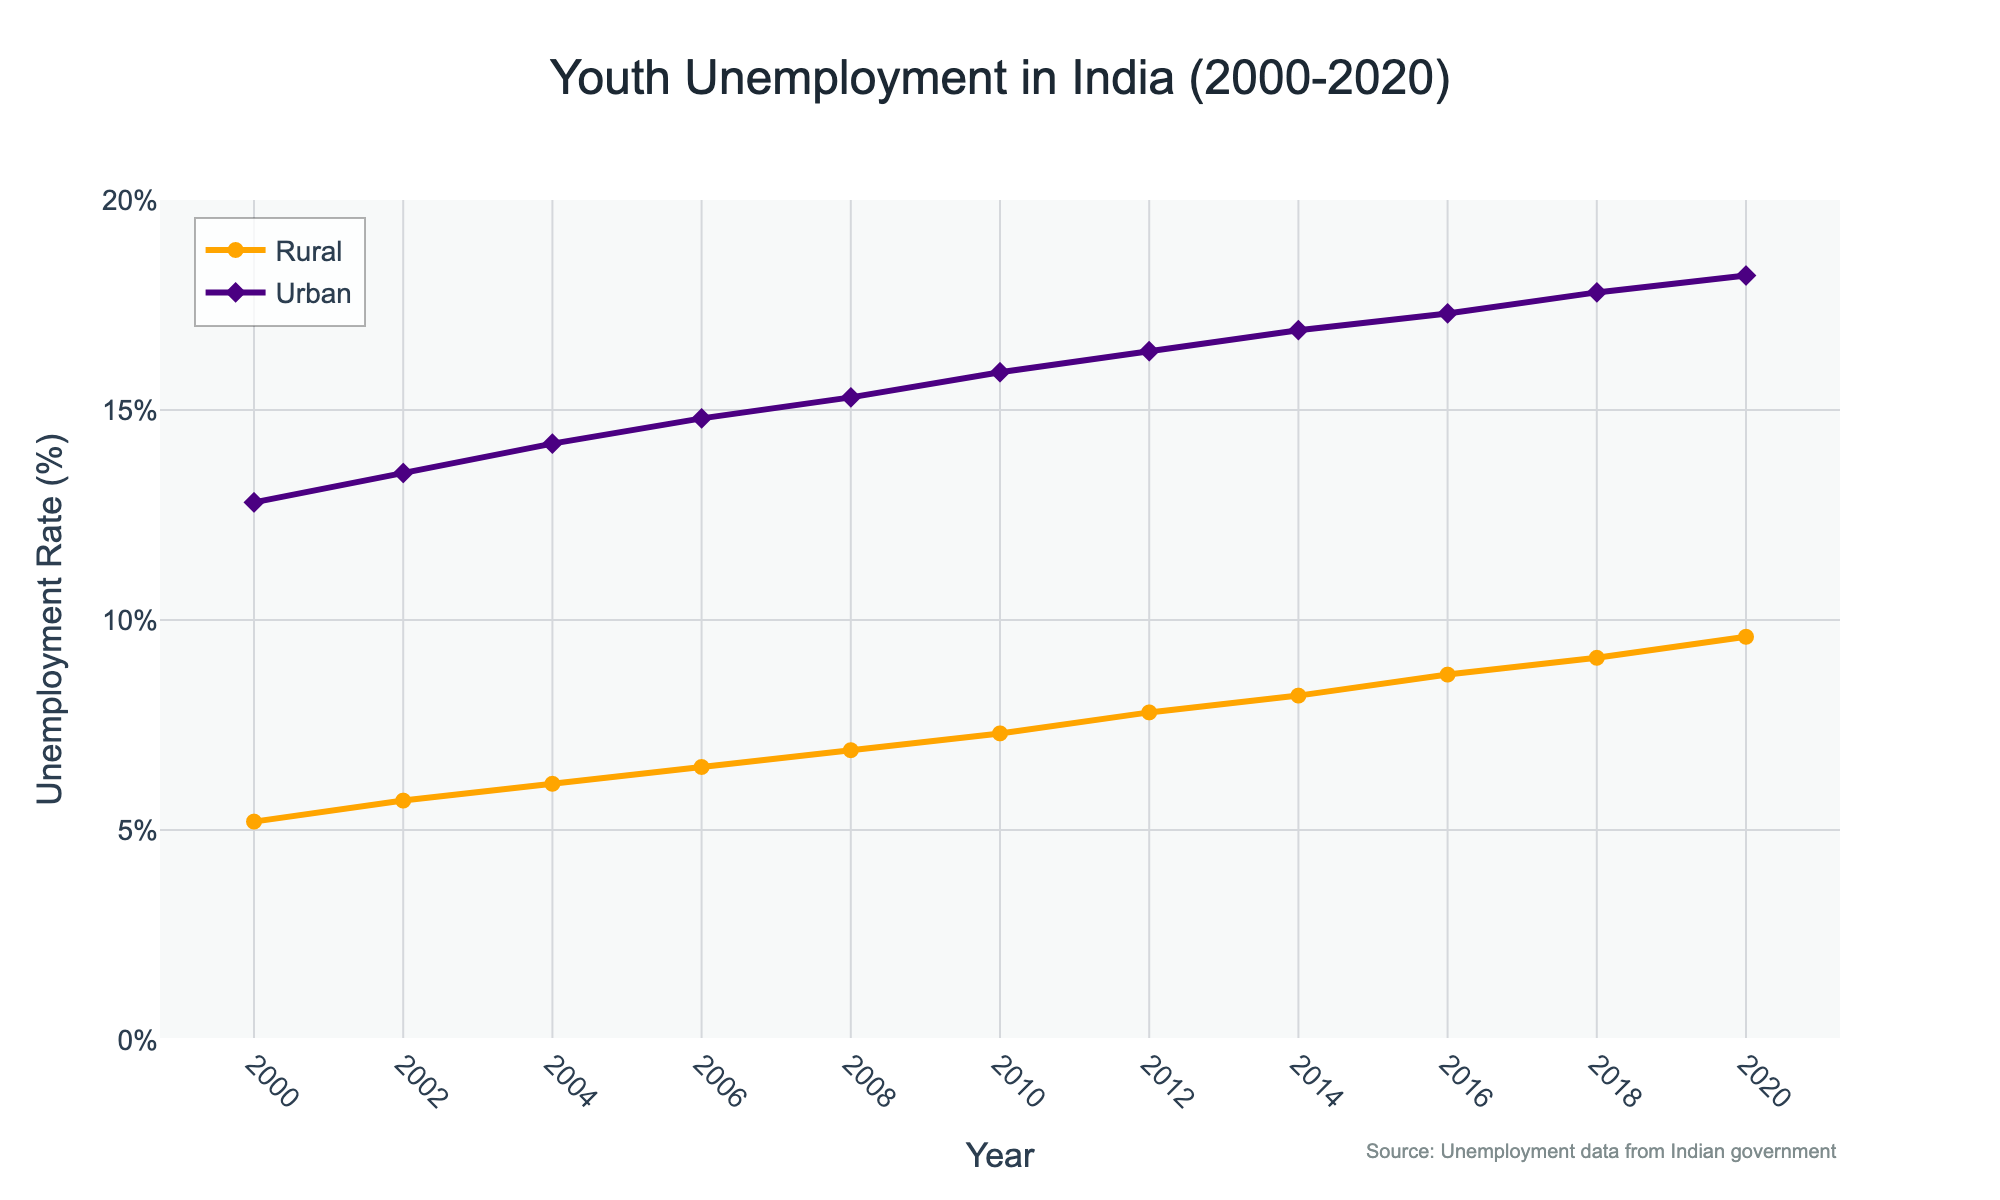What's the difference in Rural Youth Unemployment between 2000 and 2020? To find the difference, look at the unemployment rates for rural youth in 2000 and 2020. Subtract the 2000 rate from the 2020 rate: 9.6% (2020) - 5.2% (2000).
Answer: 4.4% In what year did Urban Youth Unemployment first reach 16%? Look for the year in the Urban Youth Unemployment data where the rate reaches 16% for the first time. In 2010, the rate is 15.9%, and in 2012, it's 16.4%. Since it first reaches around 16% in 2012, that's the answer.
Answer: 2012 Which group, Rural or Urban Youth, had a higher unemployment rate in 2008? Compare the unemployment rates for Rural and Urban Youth in 2008. Rural Youth have an unemployment rate of 6.9%, while Urban Youth have 15.3%. Since 15.3% is higher than 6.9%, Urban Youth was higher in 2008.
Answer: Urban Youth How does the growth trend of Rural Youth Unemployment compare to Urban Youth Unemployment from 2000 to 2020? Observe the trend lines of Rural and Urban Youth Unemployment rates from 2000 to 2020. Both show an increasing trend, but the Urban Youth Unemployment is comparatively flatter and consistently higher than the Rural Youth Unemployment, which has a steeper increase.
Answer: Rural has steeper growth What is the average unemployment rate for Rural Youth from 2000 to 2020? Sum all the Rural Youth Unemployment rates from 2000 to 2020 and divide by the number of years (11 years). (5.2 + 5.7 + 6.1 + 6.5 + 6.9 + 7.3 + 7.8 + 8.2 + 8.7 + 9.1 + 9.6) / 11 = 81.1 / 11.
Answer: 7.37% Which year showed the biggest increase in Urban Youth Unemployment since the previous recorded year? Calculate the year-on-year differences for Urban Youth Unemployment between each consecutive pair of years. The year with the largest difference is between 2002 (13.5%) and 2004 (14.2%), with an increase of 0.7%.
Answer: 2004 What is the total increase in Urban Youth Unemployment rate from 2000 to 2020? Subtract the Urban Youth Unemployment rate in 2000 (12.8%) from the rate in 2020 (18.2%).
Answer: 5.4% In which year did both Rural and Urban Youth Unemployment rates increased by the same amount from the previous recorded year? Calculate the year-on-year differences for both Rural and Urban Youth Unemployment rates. In 2014, the increases were from 7.8% to 8.2% (Rural) and 16.4% to 16.9% (Urban), both increasing by 0.4%.
Answer: 2014 How often did Rural Youth Unemployment increase over the last two decades? Count the number of times the Rural Youth Unemployment rate increased from one recorded year to the next. It increased 10 times (from each year to the next from 2000 to 2020).
Answer: 10 times Which unemployment rate was higher in 2020, Rural or Urban Youth? Compare the unemployment rates for Rural and Urban Youth in the year 2020. Rural Youth have 9.6% and Urban Youth have 18.2%. Since 18.2% is higher than 9.6%, Urban Youth was higher in 2020.
Answer: Urban Youth 